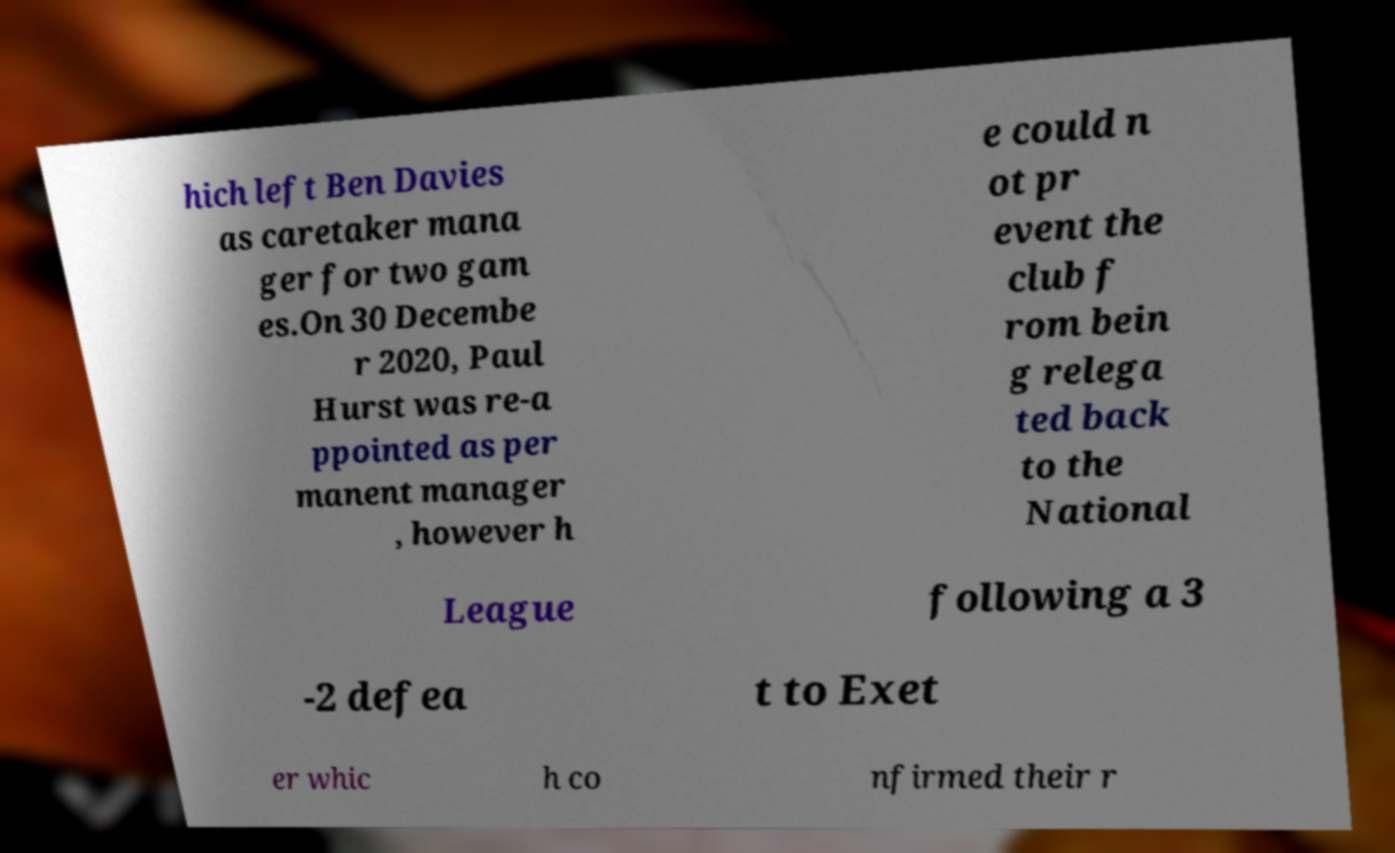Please read and relay the text visible in this image. What does it say? hich left Ben Davies as caretaker mana ger for two gam es.On 30 Decembe r 2020, Paul Hurst was re-a ppointed as per manent manager , however h e could n ot pr event the club f rom bein g relega ted back to the National League following a 3 -2 defea t to Exet er whic h co nfirmed their r 